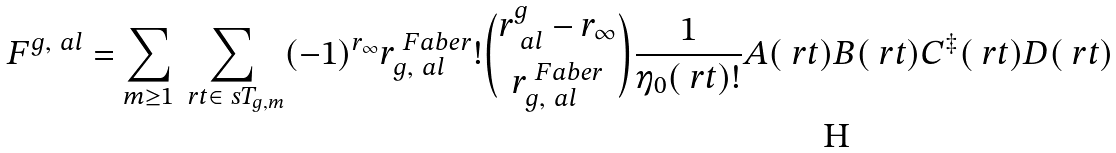<formula> <loc_0><loc_0><loc_500><loc_500>\ F ^ { g , \ a l } = \sum _ { m \geq 1 } \sum _ { \ r t \in \ s T _ { g , m } } ( - 1 ) ^ { r _ { \infty } } r ^ { \ F a b e r } _ { g , \ a l } ! \binom { r ^ { g } _ { \ a l } - r _ { \infty } } { r ^ { \ F a b e r } _ { g , \ a l } } \frac { 1 } { \eta _ { 0 } ( \ r t ) ! } A ( \ r t ) B ( \ r t ) C ^ { \ddagger } ( \ r t ) D ( \ r t )</formula> 